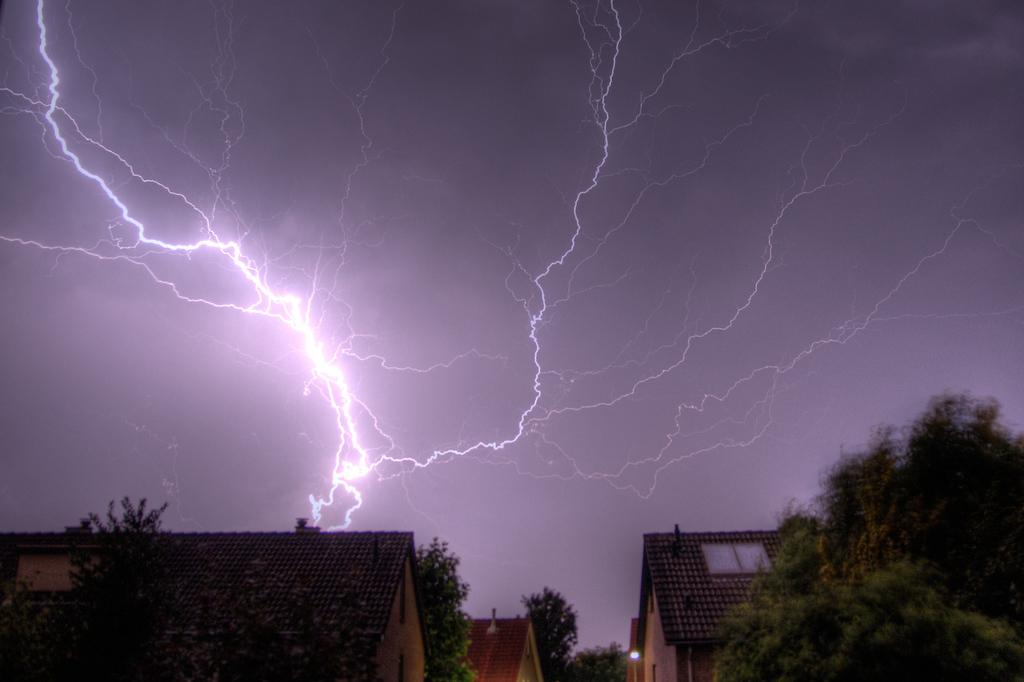What type of structures can be seen in the image? There are houses in the image. What other natural elements are present in the image? There are trees in the image. What part of the natural environment is visible in the image? The sky is visible in the image. What weather phenomenon can be observed in the sky? There is lightning in the sky. Who is the owner of the basin in the image? There is no basin present in the image. How many trains can be seen in the image? There are no trains present in the image. 